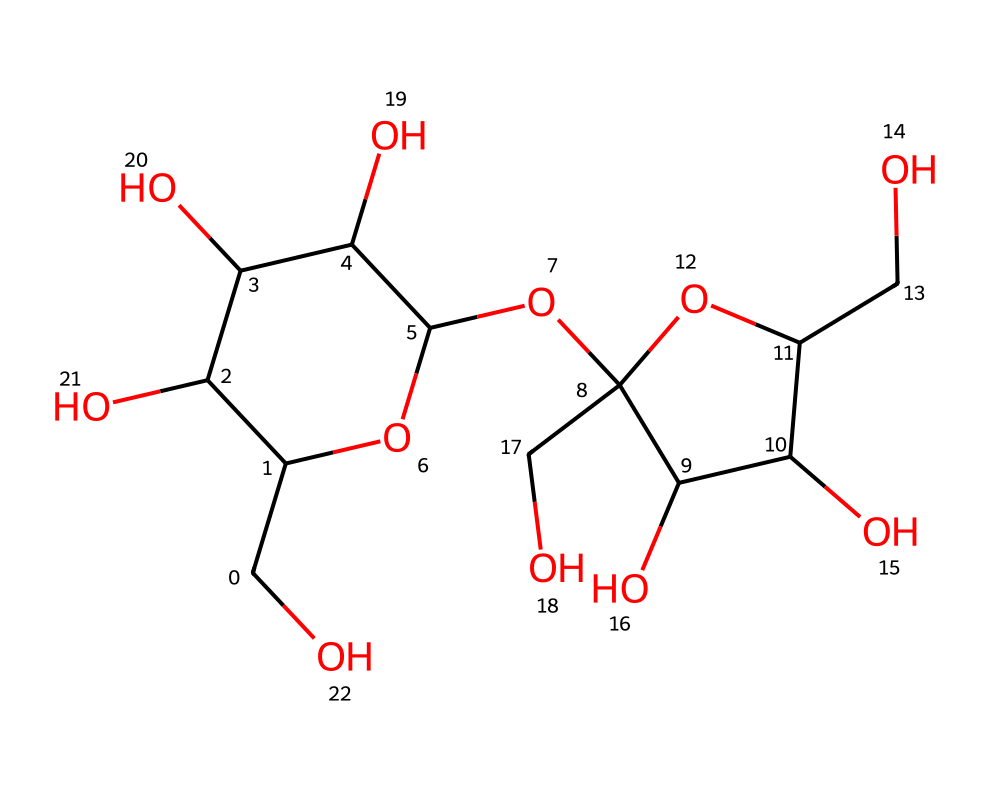What is the molecular formula of sucrose? To determine the molecular formula from the SMILES representation, we can count the carbon (C), hydrogen (H), and oxygen (O) atoms represented in the structure. The SMILES indicates 12 carbons, 22 hydrogens, and 11 oxygens. Thus, the molecular formula is C12H22O11.
Answer: C12H22O11 How many rings are present in the structure? By analyzing the SMILES representation, we can identify two ring structures marked by the numbers in the SMILES. The presence of "1" and "2" indicates the start and end of each ring structure. Therefore, there are two rings.
Answer: 2 What kind of carbohydrate is sucrose classified as? Sucrose is classified as a disaccharide, which is a carbohydrate formed by the combination of two monosaccharides. Specifically, sucrose is formed from glucose and fructose.
Answer: disaccharide How many hydroxyl (–OH) groups are present in sucrose? In the structure of sucrose, hydroxyl groups can be identified by looking for the "O" atoms that are connected to hydrogen atoms (as shown by the “O” and surrounding carbon atoms). Counting these in the structure reveals that there are 5 hydroxyl groups.
Answer: 5 What functional groups are present in sucrose? Sucrose contains hydroxyl (–OH) functional groups and an acetal linkage (formed from the glycosidic bond between the two monosaccharides). The SMILES shows multiple oxygen atoms connected to carbons, indicating these functional groups.
Answer: hydroxyl and acetal What is the configuration of sucrose at the anomeric carbon? The anomeric carbon in sucrose is derived from the glucose component of the structure. In the SMILES representation, the orientation of the substituents around this anomeric center (the carbon bonded to two oxygens and another carbon) allows us to identify it as having a specific configuration, which is generally α or β. In this case, sucrose is an α-configuration at the anomeric carbon.
Answer: α How many total carbon atoms are in the sucrose structure? Counting the carbon atoms listed in the SMILES notation gives us the total number of carbon atoms in sucrose. There are 12 carbon atoms depicted in the structure which confirms this count.
Answer: 12 